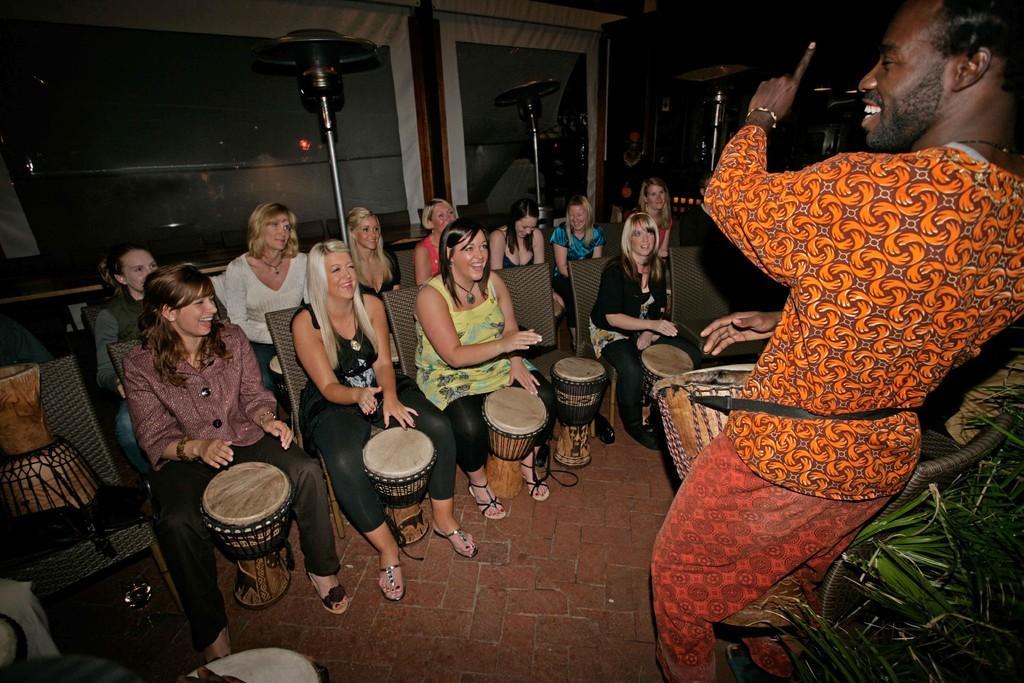In one or two sentences, can you explain what this image depicts? In this image there are group of woman who are sitting on the chairs is listening to the man who is in front of them. All the women are holding the drums. At the back side there is a curtain. To the right side there are small leaves. 